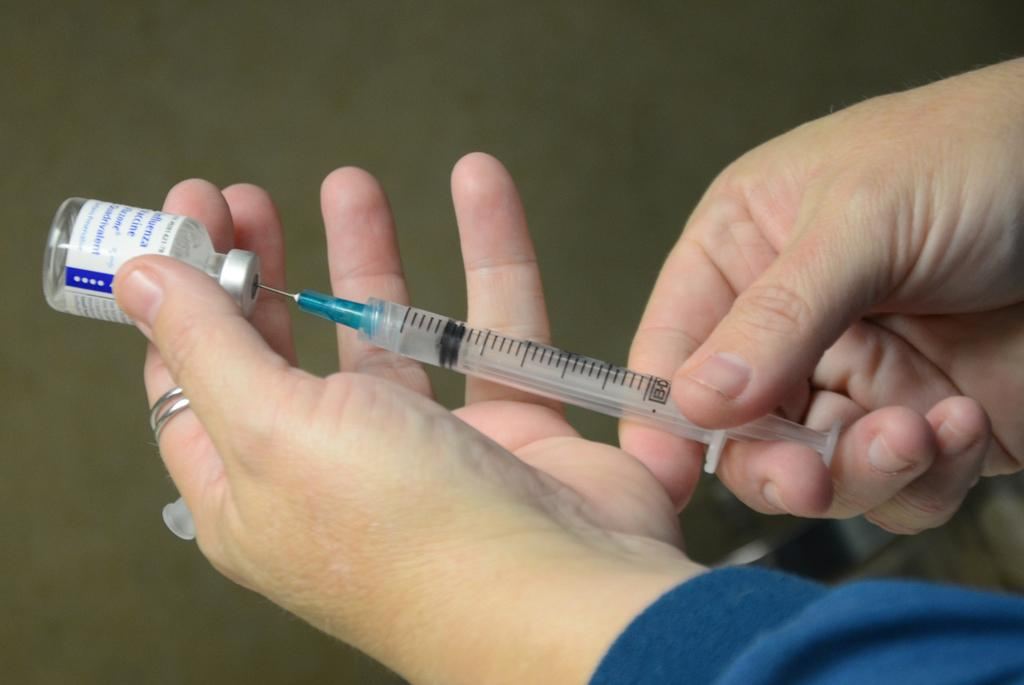What is the main subject of the image? There is a human in the image. What is the human holding in the image? The human is holding a syringe and a medicine bottle. How many boys are present in the image? There is no mention of boys in the image, as the main subject is a human holding a syringe and a medicine bottle. What type of notebook is the grandfather using in the image? There is no mention of a notebook or a grandfather in the image. 